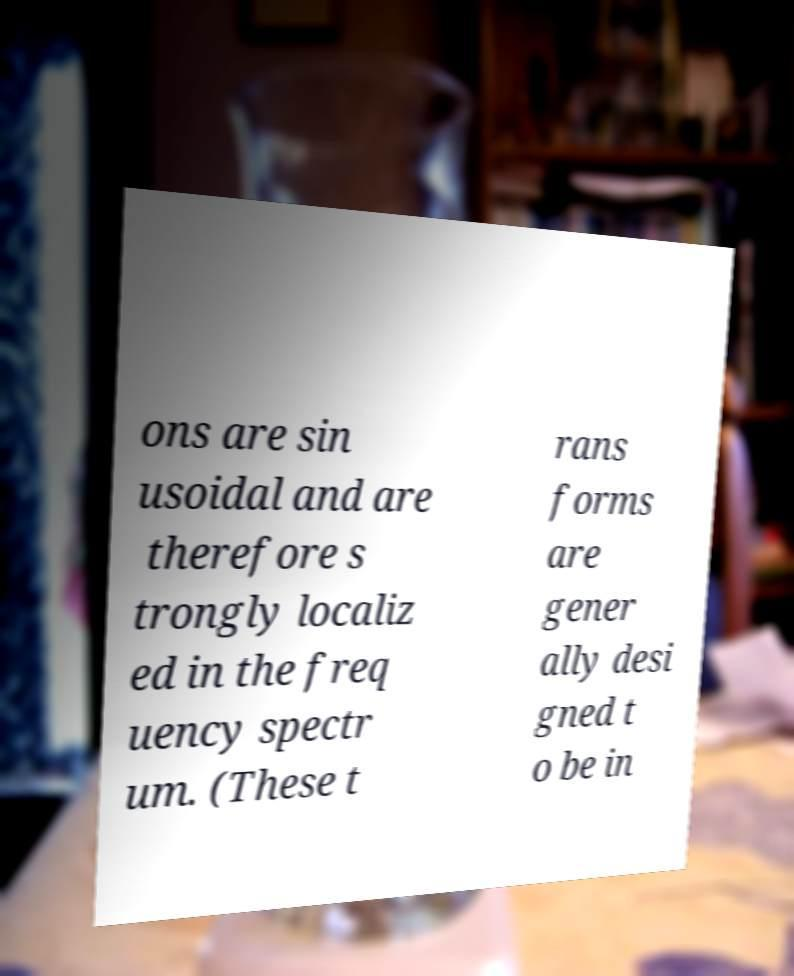Please read and relay the text visible in this image. What does it say? ons are sin usoidal and are therefore s trongly localiz ed in the freq uency spectr um. (These t rans forms are gener ally desi gned t o be in 